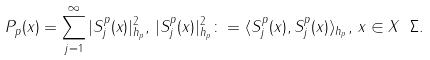<formula> <loc_0><loc_0><loc_500><loc_500>P _ { p } ( x ) = \sum _ { j = 1 } ^ { \infty } | S ^ { p } _ { j } ( x ) | _ { h _ { p } } ^ { 2 } , \, | S ^ { p } _ { j } ( x ) | _ { h _ { p } } ^ { 2 } \colon = \langle S _ { j } ^ { p } ( x ) , S _ { j } ^ { p } ( x ) \rangle _ { h _ { p } } , \, x \in X \ \Sigma .</formula> 